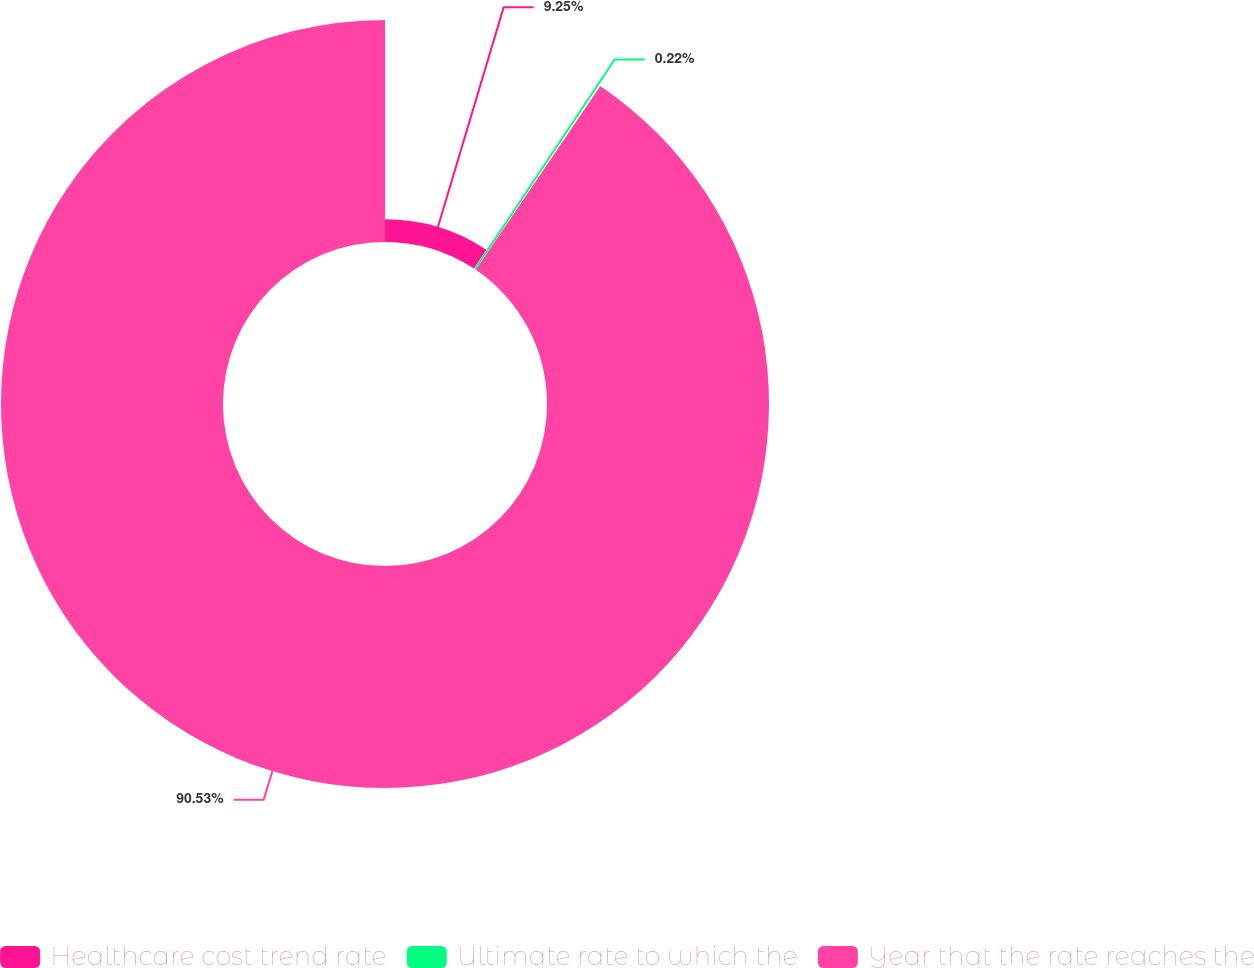<chart> <loc_0><loc_0><loc_500><loc_500><pie_chart><fcel>Healthcare cost trend rate<fcel>Ultimate rate to which the<fcel>Year that the rate reaches the<nl><fcel>9.25%<fcel>0.22%<fcel>90.52%<nl></chart> 